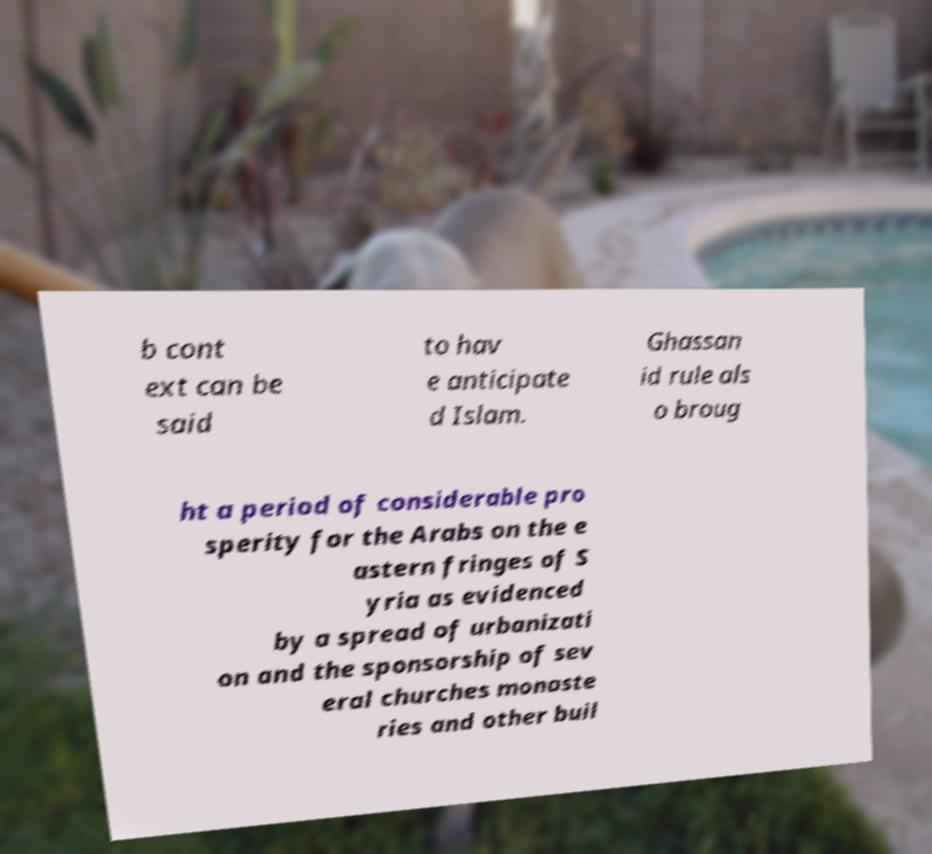Can you accurately transcribe the text from the provided image for me? b cont ext can be said to hav e anticipate d Islam. Ghassan id rule als o broug ht a period of considerable pro sperity for the Arabs on the e astern fringes of S yria as evidenced by a spread of urbanizati on and the sponsorship of sev eral churches monaste ries and other buil 